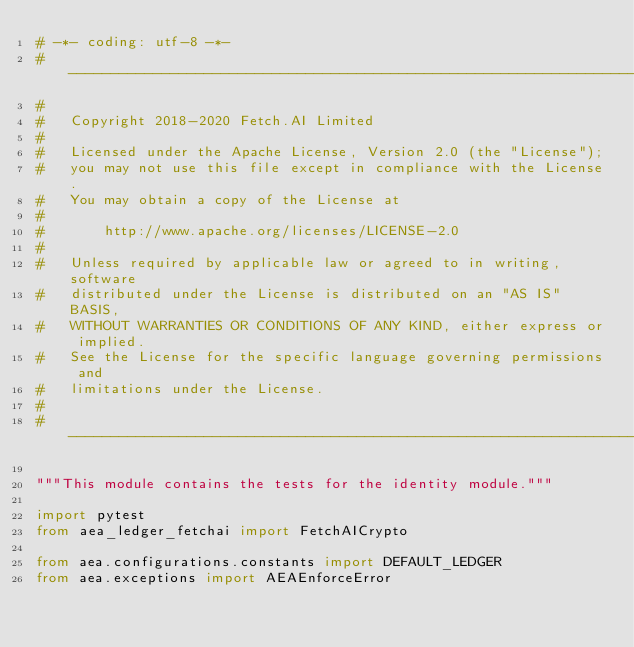<code> <loc_0><loc_0><loc_500><loc_500><_Python_># -*- coding: utf-8 -*-
# ------------------------------------------------------------------------------
#
#   Copyright 2018-2020 Fetch.AI Limited
#
#   Licensed under the Apache License, Version 2.0 (the "License");
#   you may not use this file except in compliance with the License.
#   You may obtain a copy of the License at
#
#       http://www.apache.org/licenses/LICENSE-2.0
#
#   Unless required by applicable law or agreed to in writing, software
#   distributed under the License is distributed on an "AS IS" BASIS,
#   WITHOUT WARRANTIES OR CONDITIONS OF ANY KIND, either express or implied.
#   See the License for the specific language governing permissions and
#   limitations under the License.
#
# ------------------------------------------------------------------------------

"""This module contains the tests for the identity module."""

import pytest
from aea_ledger_fetchai import FetchAICrypto

from aea.configurations.constants import DEFAULT_LEDGER
from aea.exceptions import AEAEnforceError</code> 